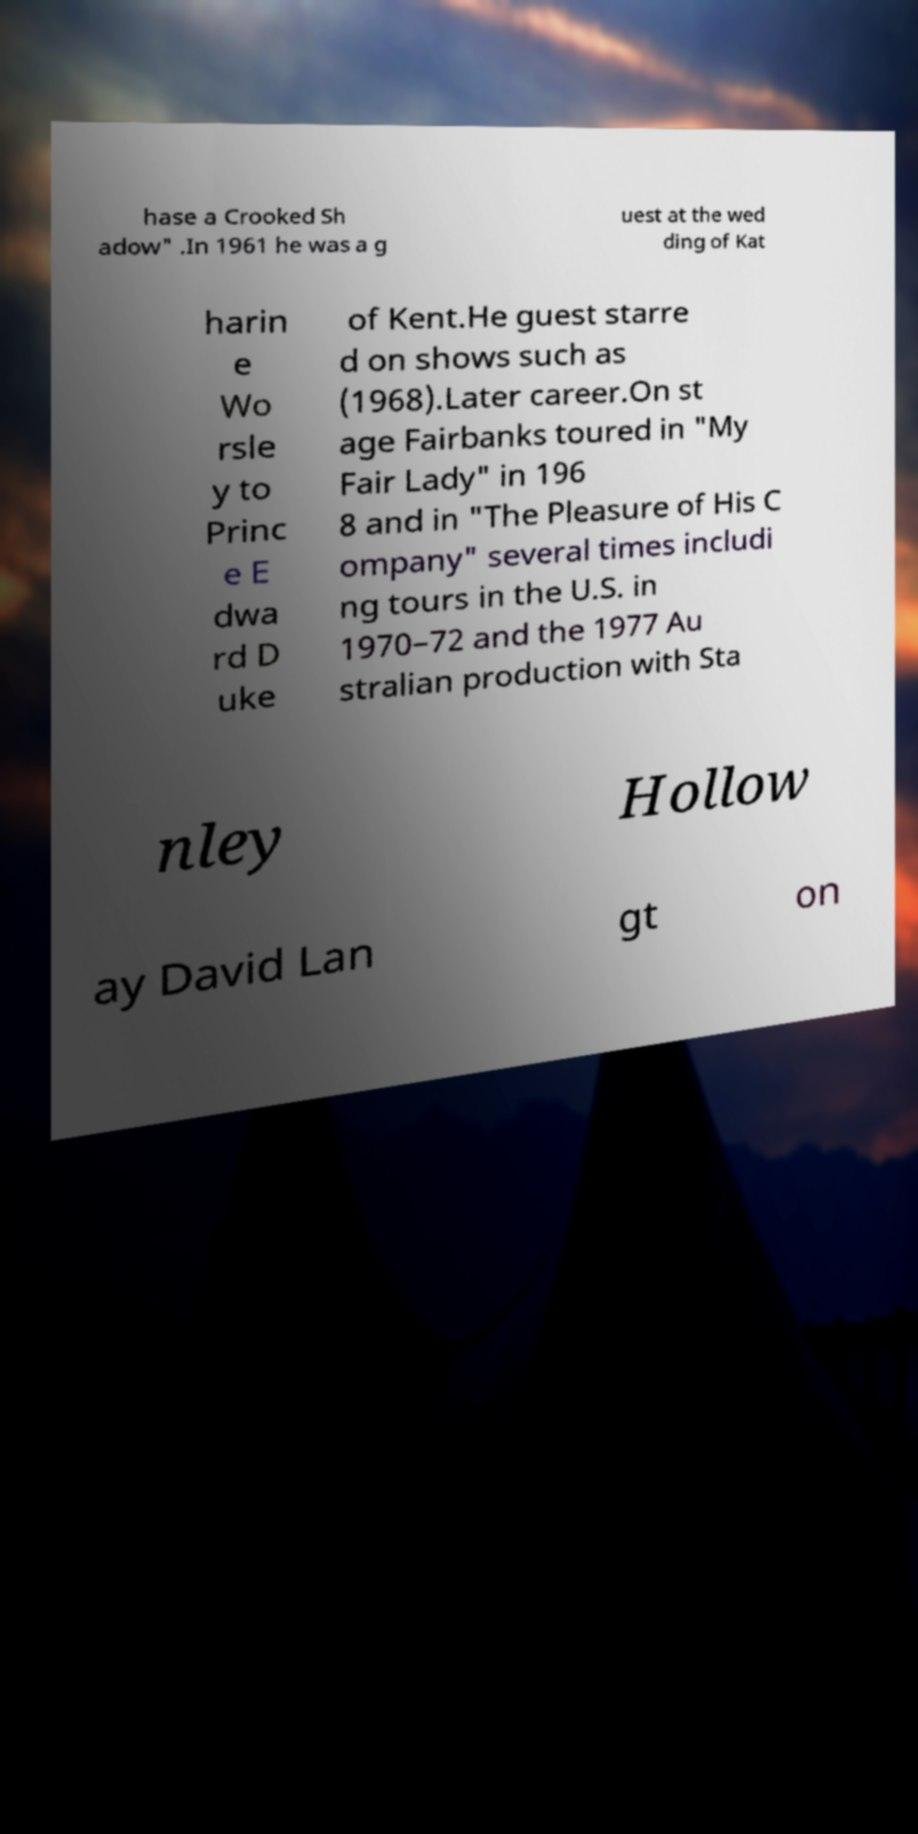Can you read and provide the text displayed in the image?This photo seems to have some interesting text. Can you extract and type it out for me? hase a Crooked Sh adow" .In 1961 he was a g uest at the wed ding of Kat harin e Wo rsle y to Princ e E dwa rd D uke of Kent.He guest starre d on shows such as (1968).Later career.On st age Fairbanks toured in "My Fair Lady" in 196 8 and in "The Pleasure of His C ompany" several times includi ng tours in the U.S. in 1970–72 and the 1977 Au stralian production with Sta nley Hollow ay David Lan gt on 